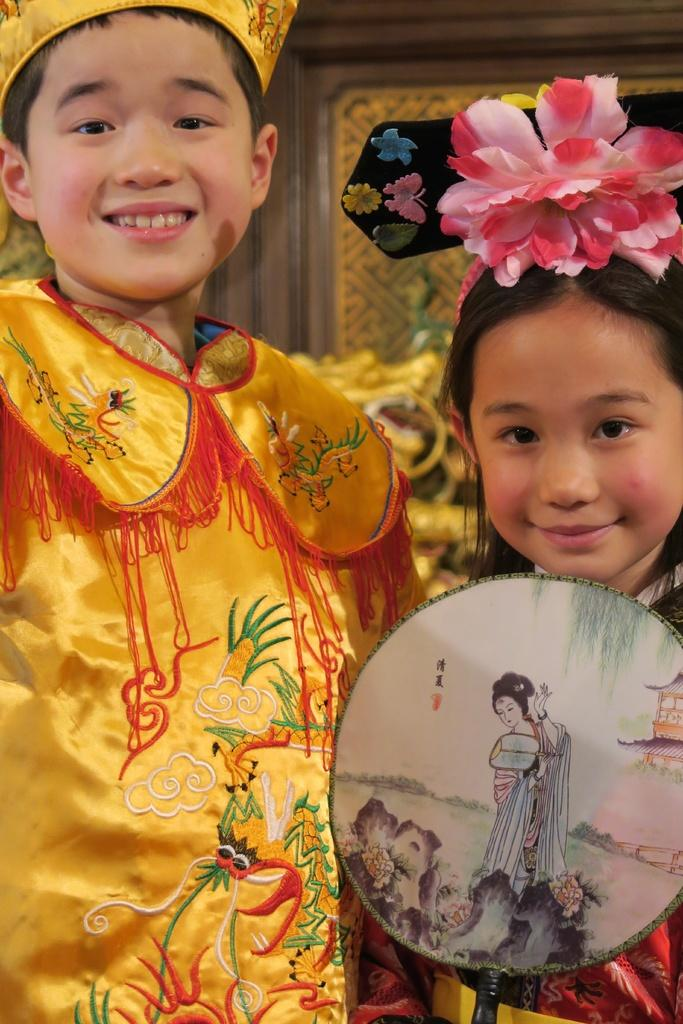How many children are in the image? There are two children in the image. Can you describe the children in terms of gender? One of the children is a boy, and the other child is a girl. What are the children wearing? Both children are wearing the same dresses. What is the girl holding in the image? The girl is holding something. What color is the dress the boy is wearing? The boy is wearing a yellow color dress. What type of engine can be seen in the image? There is no engine present in the image. What kind of pancake is the girl eating in the image? There is no pancake present in the image. 